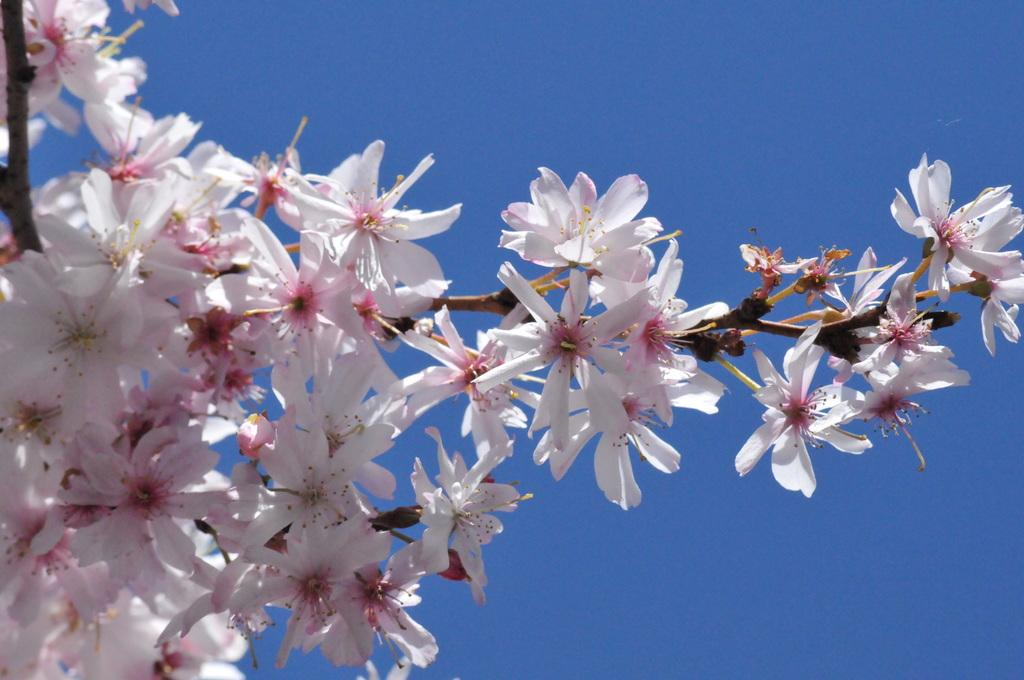What type of tree is present in the image? There is a tree with flowers in the image. What stage of growth are the flowers on the tree in? The tree has buds. What can be seen in the background of the image? There is sky visible in the background of the image. How much salt is on the tree in the image? There is no salt present on the tree in the image. 